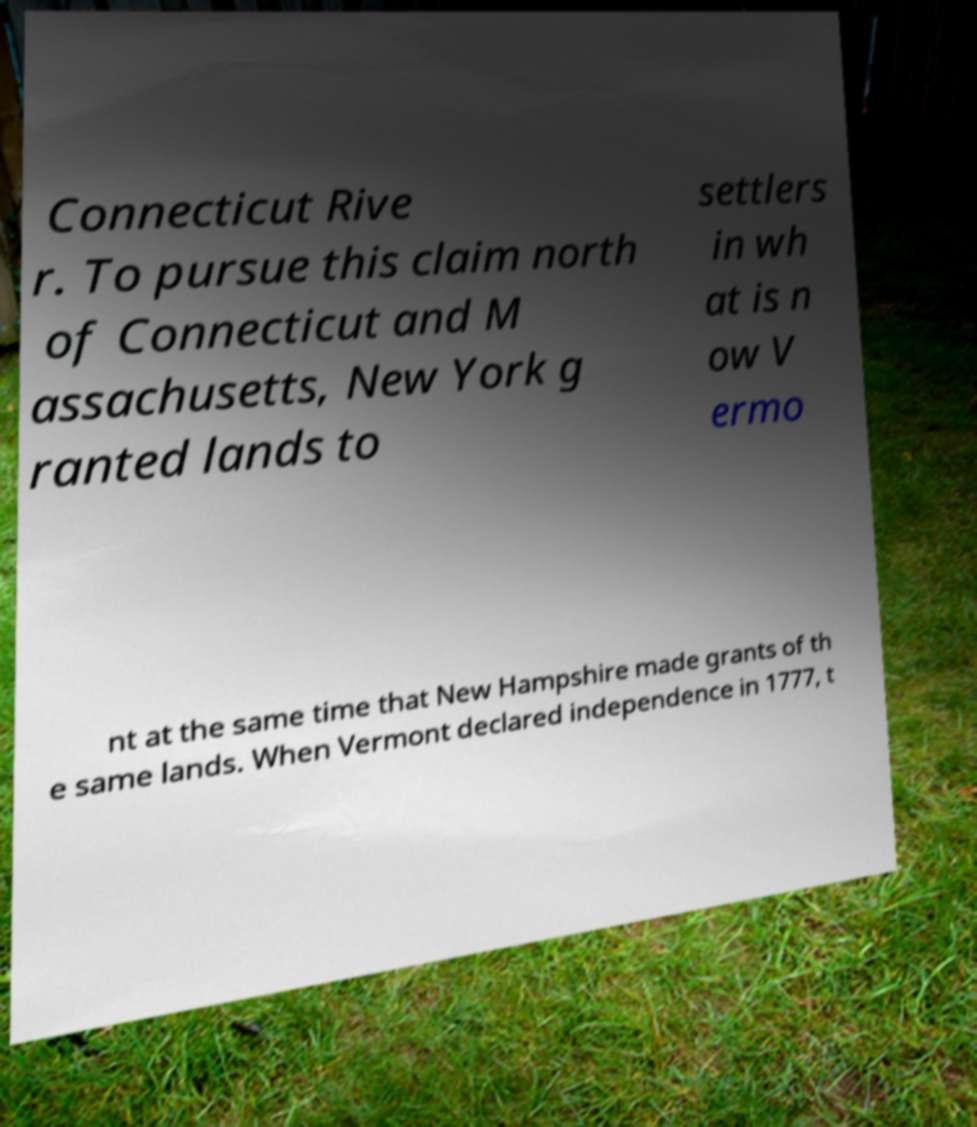What messages or text are displayed in this image? I need them in a readable, typed format. Connecticut Rive r. To pursue this claim north of Connecticut and M assachusetts, New York g ranted lands to settlers in wh at is n ow V ermo nt at the same time that New Hampshire made grants of th e same lands. When Vermont declared independence in 1777, t 